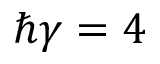Convert formula to latex. <formula><loc_0><loc_0><loc_500><loc_500>\hbar { \gamma } = 4</formula> 